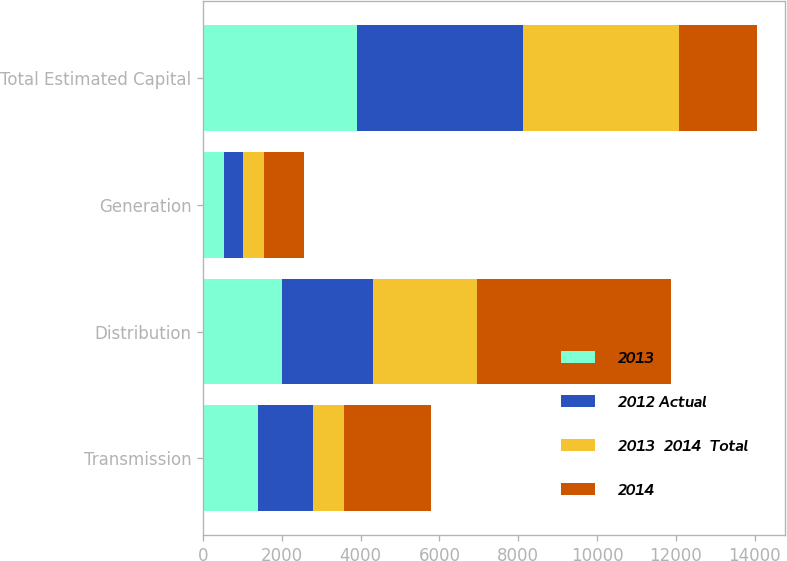Convert chart to OTSL. <chart><loc_0><loc_0><loc_500><loc_500><stacked_bar_chart><ecel><fcel>Transmission<fcel>Distribution<fcel>Generation<fcel>Total Estimated Capital<nl><fcel>2013<fcel>1390<fcel>1995<fcel>526<fcel>3911<nl><fcel>2012 Actual<fcel>1396<fcel>2329<fcel>485<fcel>4210<nl><fcel>2013  2014  Total<fcel>802<fcel>2617<fcel>532<fcel>3951<nl><fcel>2014<fcel>2198<fcel>4946<fcel>1017<fcel>1995<nl></chart> 